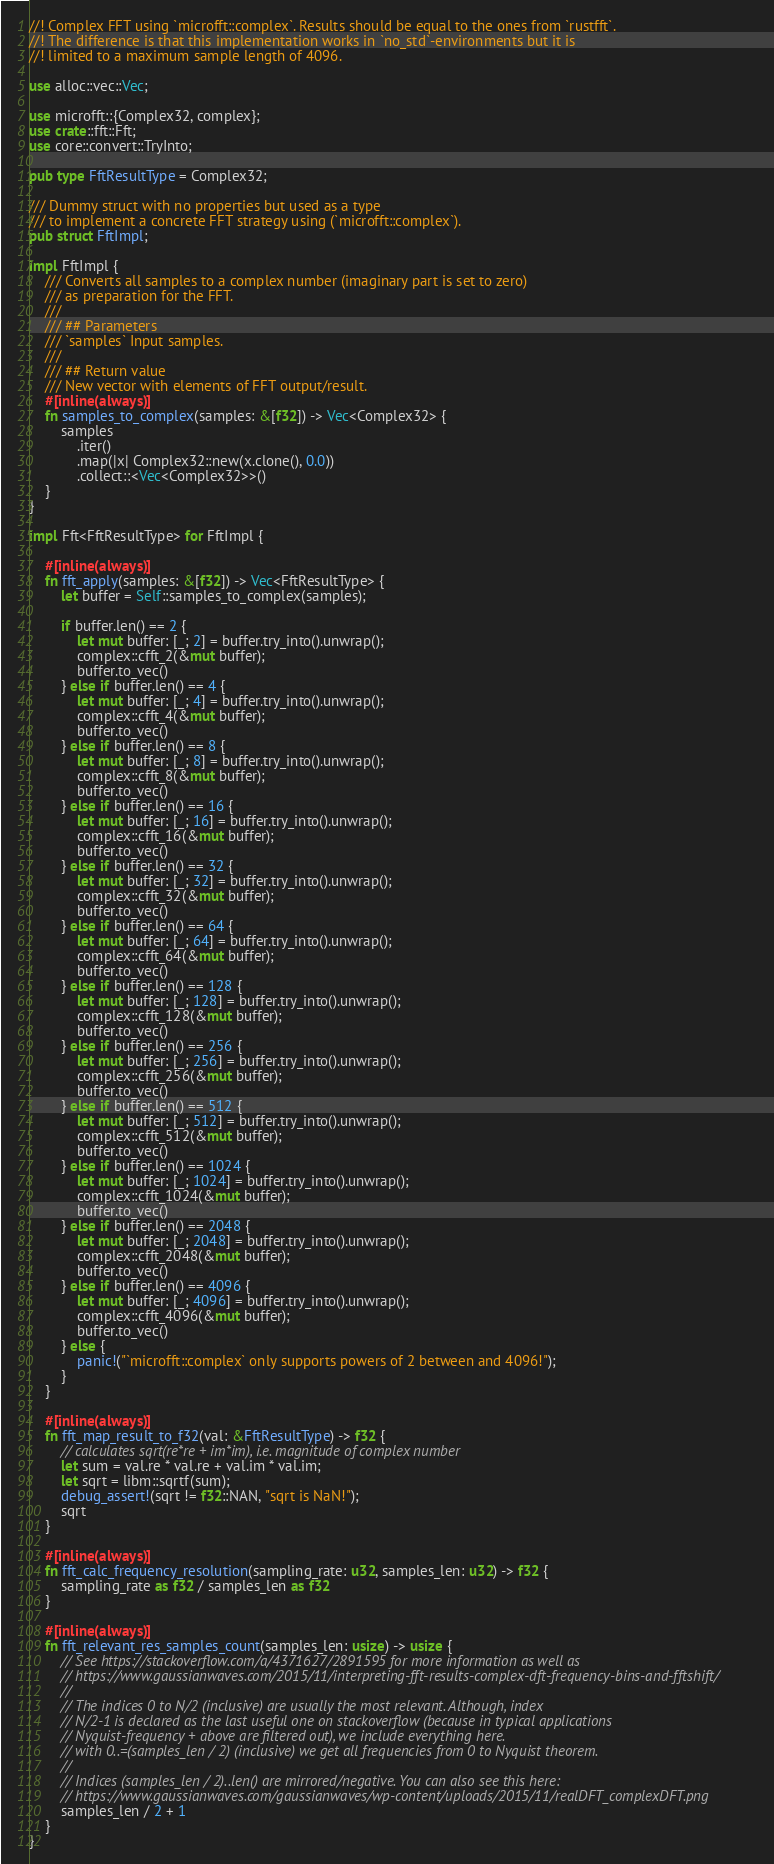Convert code to text. <code><loc_0><loc_0><loc_500><loc_500><_Rust_>//! Complex FFT using `microfft::complex`. Results should be equal to the ones from `rustfft`.
//! The difference is that this implementation works in `no_std`-environments but it is
//! limited to a maximum sample length of 4096.

use alloc::vec::Vec;

use microfft::{Complex32, complex};
use crate::fft::Fft;
use core::convert::TryInto;

pub type FftResultType = Complex32;

/// Dummy struct with no properties but used as a type
/// to implement a concrete FFT strategy using (`microfft::complex`).
pub struct FftImpl;

impl FftImpl {
    /// Converts all samples to a complex number (imaginary part is set to zero)
    /// as preparation for the FFT.
    ///
    /// ## Parameters
    /// `samples` Input samples.
    ///
    /// ## Return value
    /// New vector with elements of FFT output/result.
    #[inline(always)]
    fn samples_to_complex(samples: &[f32]) -> Vec<Complex32> {
        samples
            .iter()
            .map(|x| Complex32::new(x.clone(), 0.0))
            .collect::<Vec<Complex32>>()
    }
}

impl Fft<FftResultType> for FftImpl {

    #[inline(always)]
    fn fft_apply(samples: &[f32]) -> Vec<FftResultType> {
        let buffer = Self::samples_to_complex(samples);

        if buffer.len() == 2 {
            let mut buffer: [_; 2] = buffer.try_into().unwrap();
            complex::cfft_2(&mut buffer);
            buffer.to_vec()
        } else if buffer.len() == 4 {
            let mut buffer: [_; 4] = buffer.try_into().unwrap();
            complex::cfft_4(&mut buffer);
            buffer.to_vec()
        } else if buffer.len() == 8 {
            let mut buffer: [_; 8] = buffer.try_into().unwrap();
            complex::cfft_8(&mut buffer);
            buffer.to_vec()
        } else if buffer.len() == 16 {
            let mut buffer: [_; 16] = buffer.try_into().unwrap();
            complex::cfft_16(&mut buffer);
            buffer.to_vec()
        } else if buffer.len() == 32 {
            let mut buffer: [_; 32] = buffer.try_into().unwrap();
            complex::cfft_32(&mut buffer);
            buffer.to_vec()
        } else if buffer.len() == 64 {
            let mut buffer: [_; 64] = buffer.try_into().unwrap();
            complex::cfft_64(&mut buffer);
            buffer.to_vec()
        } else if buffer.len() == 128 {
            let mut buffer: [_; 128] = buffer.try_into().unwrap();
            complex::cfft_128(&mut buffer);
            buffer.to_vec()
        } else if buffer.len() == 256 {
            let mut buffer: [_; 256] = buffer.try_into().unwrap();
            complex::cfft_256(&mut buffer);
            buffer.to_vec()
        } else if buffer.len() == 512 {
            let mut buffer: [_; 512] = buffer.try_into().unwrap();
            complex::cfft_512(&mut buffer);
            buffer.to_vec()
        } else if buffer.len() == 1024 {
            let mut buffer: [_; 1024] = buffer.try_into().unwrap();
            complex::cfft_1024(&mut buffer);
            buffer.to_vec()
        } else if buffer.len() == 2048 {
            let mut buffer: [_; 2048] = buffer.try_into().unwrap();
            complex::cfft_2048(&mut buffer);
            buffer.to_vec()
        } else if buffer.len() == 4096 {
            let mut buffer: [_; 4096] = buffer.try_into().unwrap();
            complex::cfft_4096(&mut buffer);
            buffer.to_vec()
        } else {
            panic!("`microfft::complex` only supports powers of 2 between and 4096!");
        }
    }

    #[inline(always)]
    fn fft_map_result_to_f32(val: &FftResultType) -> f32 {
        // calculates sqrt(re*re + im*im), i.e. magnitude of complex number
        let sum = val.re * val.re + val.im * val.im;
        let sqrt = libm::sqrtf(sum);
        debug_assert!(sqrt != f32::NAN, "sqrt is NaN!");
        sqrt
    }

    #[inline(always)]
    fn fft_calc_frequency_resolution(sampling_rate: u32, samples_len: u32) -> f32 {
        sampling_rate as f32 / samples_len as f32
    }

    #[inline(always)]
    fn fft_relevant_res_samples_count(samples_len: usize) -> usize {
        // See https://stackoverflow.com/a/4371627/2891595 for more information as well as
        // https://www.gaussianwaves.com/2015/11/interpreting-fft-results-complex-dft-frequency-bins-and-fftshift/
        //
        // The indices 0 to N/2 (inclusive) are usually the most relevant. Although, index
        // N/2-1 is declared as the last useful one on stackoverflow (because in typical applications
        // Nyquist-frequency + above are filtered out), we include everything here.
        // with 0..=(samples_len / 2) (inclusive) we get all frequencies from 0 to Nyquist theorem.
        //
        // Indices (samples_len / 2)..len() are mirrored/negative. You can also see this here:
        // https://www.gaussianwaves.com/gaussianwaves/wp-content/uploads/2015/11/realDFT_complexDFT.png
        samples_len / 2 + 1
    }
}
</code> 